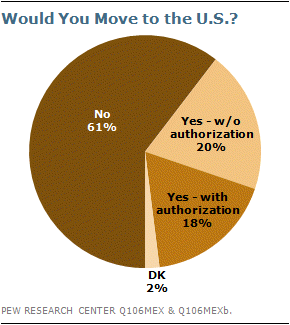Indicate a few pertinent items in this graphic. We divided the second smallest segment by the smallest segment, and the result was 9. Of the respondents surveyed, 0.61% stated that they would not move to the United States. 